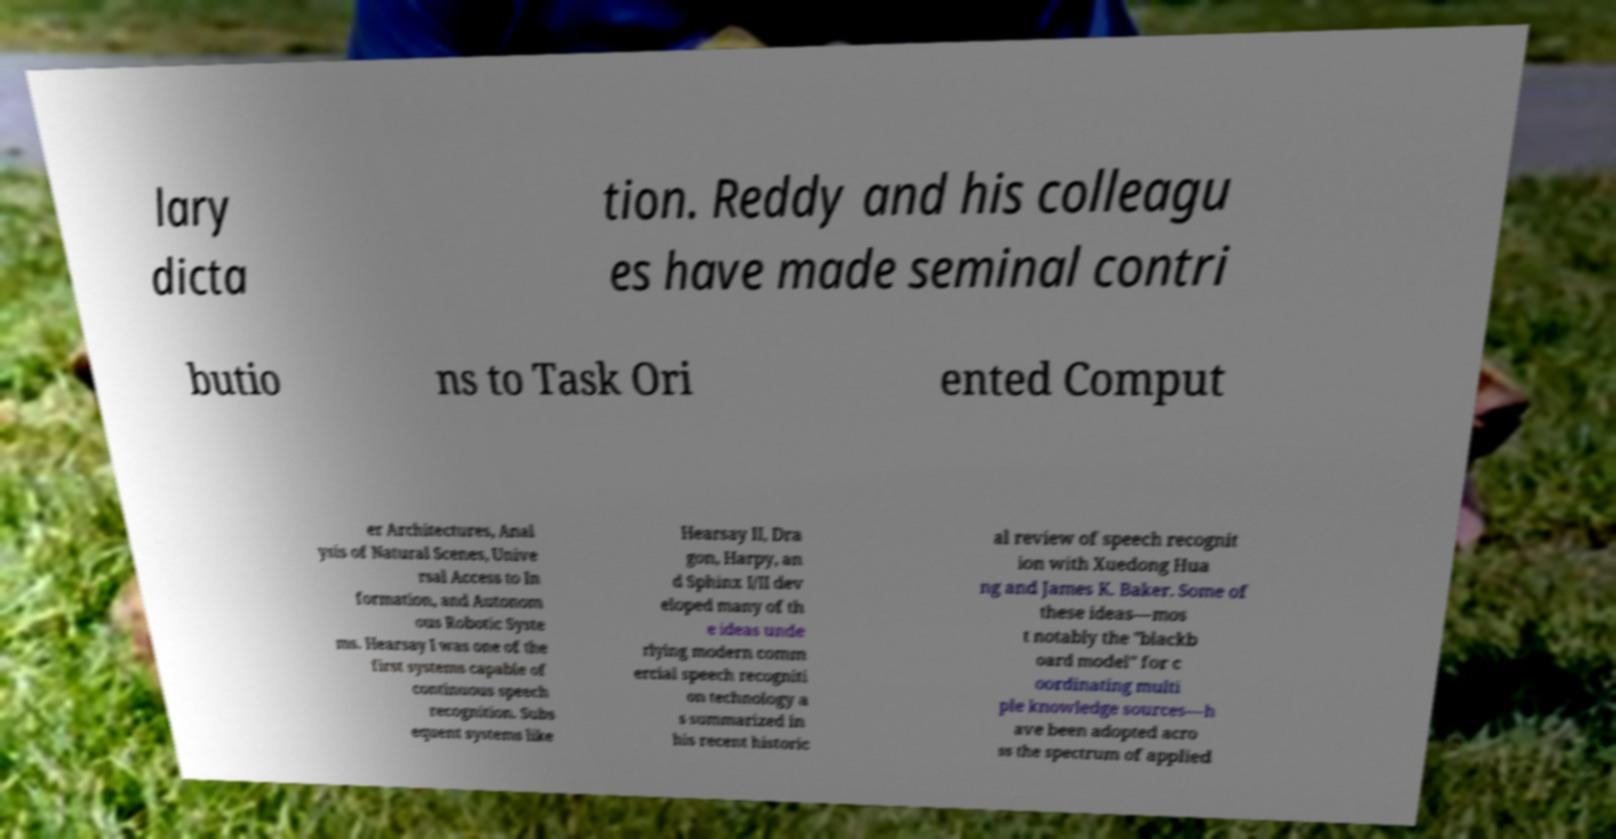There's text embedded in this image that I need extracted. Can you transcribe it verbatim? lary dicta tion. Reddy and his colleagu es have made seminal contri butio ns to Task Ori ented Comput er Architectures, Anal ysis of Natural Scenes, Unive rsal Access to In formation, and Autonom ous Robotic Syste ms. Hearsay I was one of the first systems capable of continuous speech recognition. Subs equent systems like Hearsay II, Dra gon, Harpy, an d Sphinx I/II dev eloped many of th e ideas unde rlying modern comm ercial speech recogniti on technology a s summarized in his recent historic al review of speech recognit ion with Xuedong Hua ng and James K. Baker. Some of these ideas—mos t notably the "blackb oard model" for c oordinating multi ple knowledge sources—h ave been adopted acro ss the spectrum of applied 